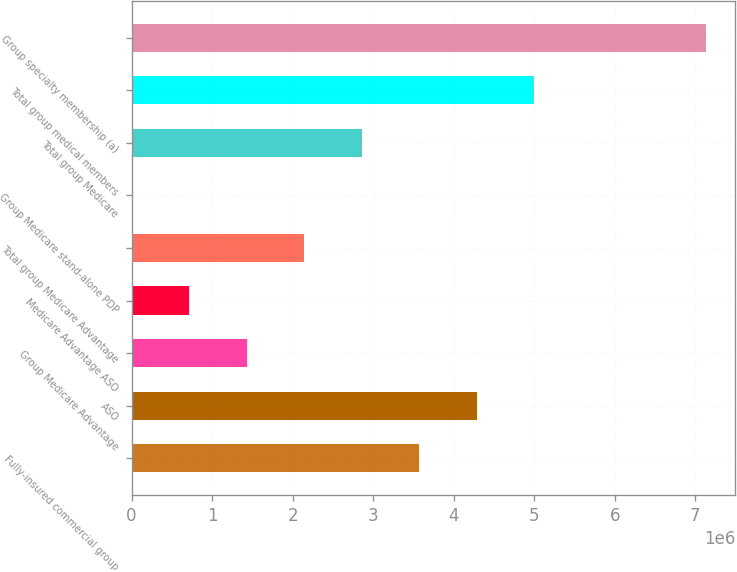Convert chart. <chart><loc_0><loc_0><loc_500><loc_500><bar_chart><fcel>Fully-insured commercial group<fcel>ASO<fcel>Group Medicare Advantage<fcel>Medicare Advantage ASO<fcel>Total group Medicare Advantage<fcel>Group Medicare stand-alone PDP<fcel>Total group Medicare<fcel>Total group medical members<fcel>Group specialty membership (a)<nl><fcel>3.5703e+06<fcel>4.28348e+06<fcel>1.43076e+06<fcel>717580<fcel>2.14394e+06<fcel>4400<fcel>2.85712e+06<fcel>4.99666e+06<fcel>7.1362e+06<nl></chart> 